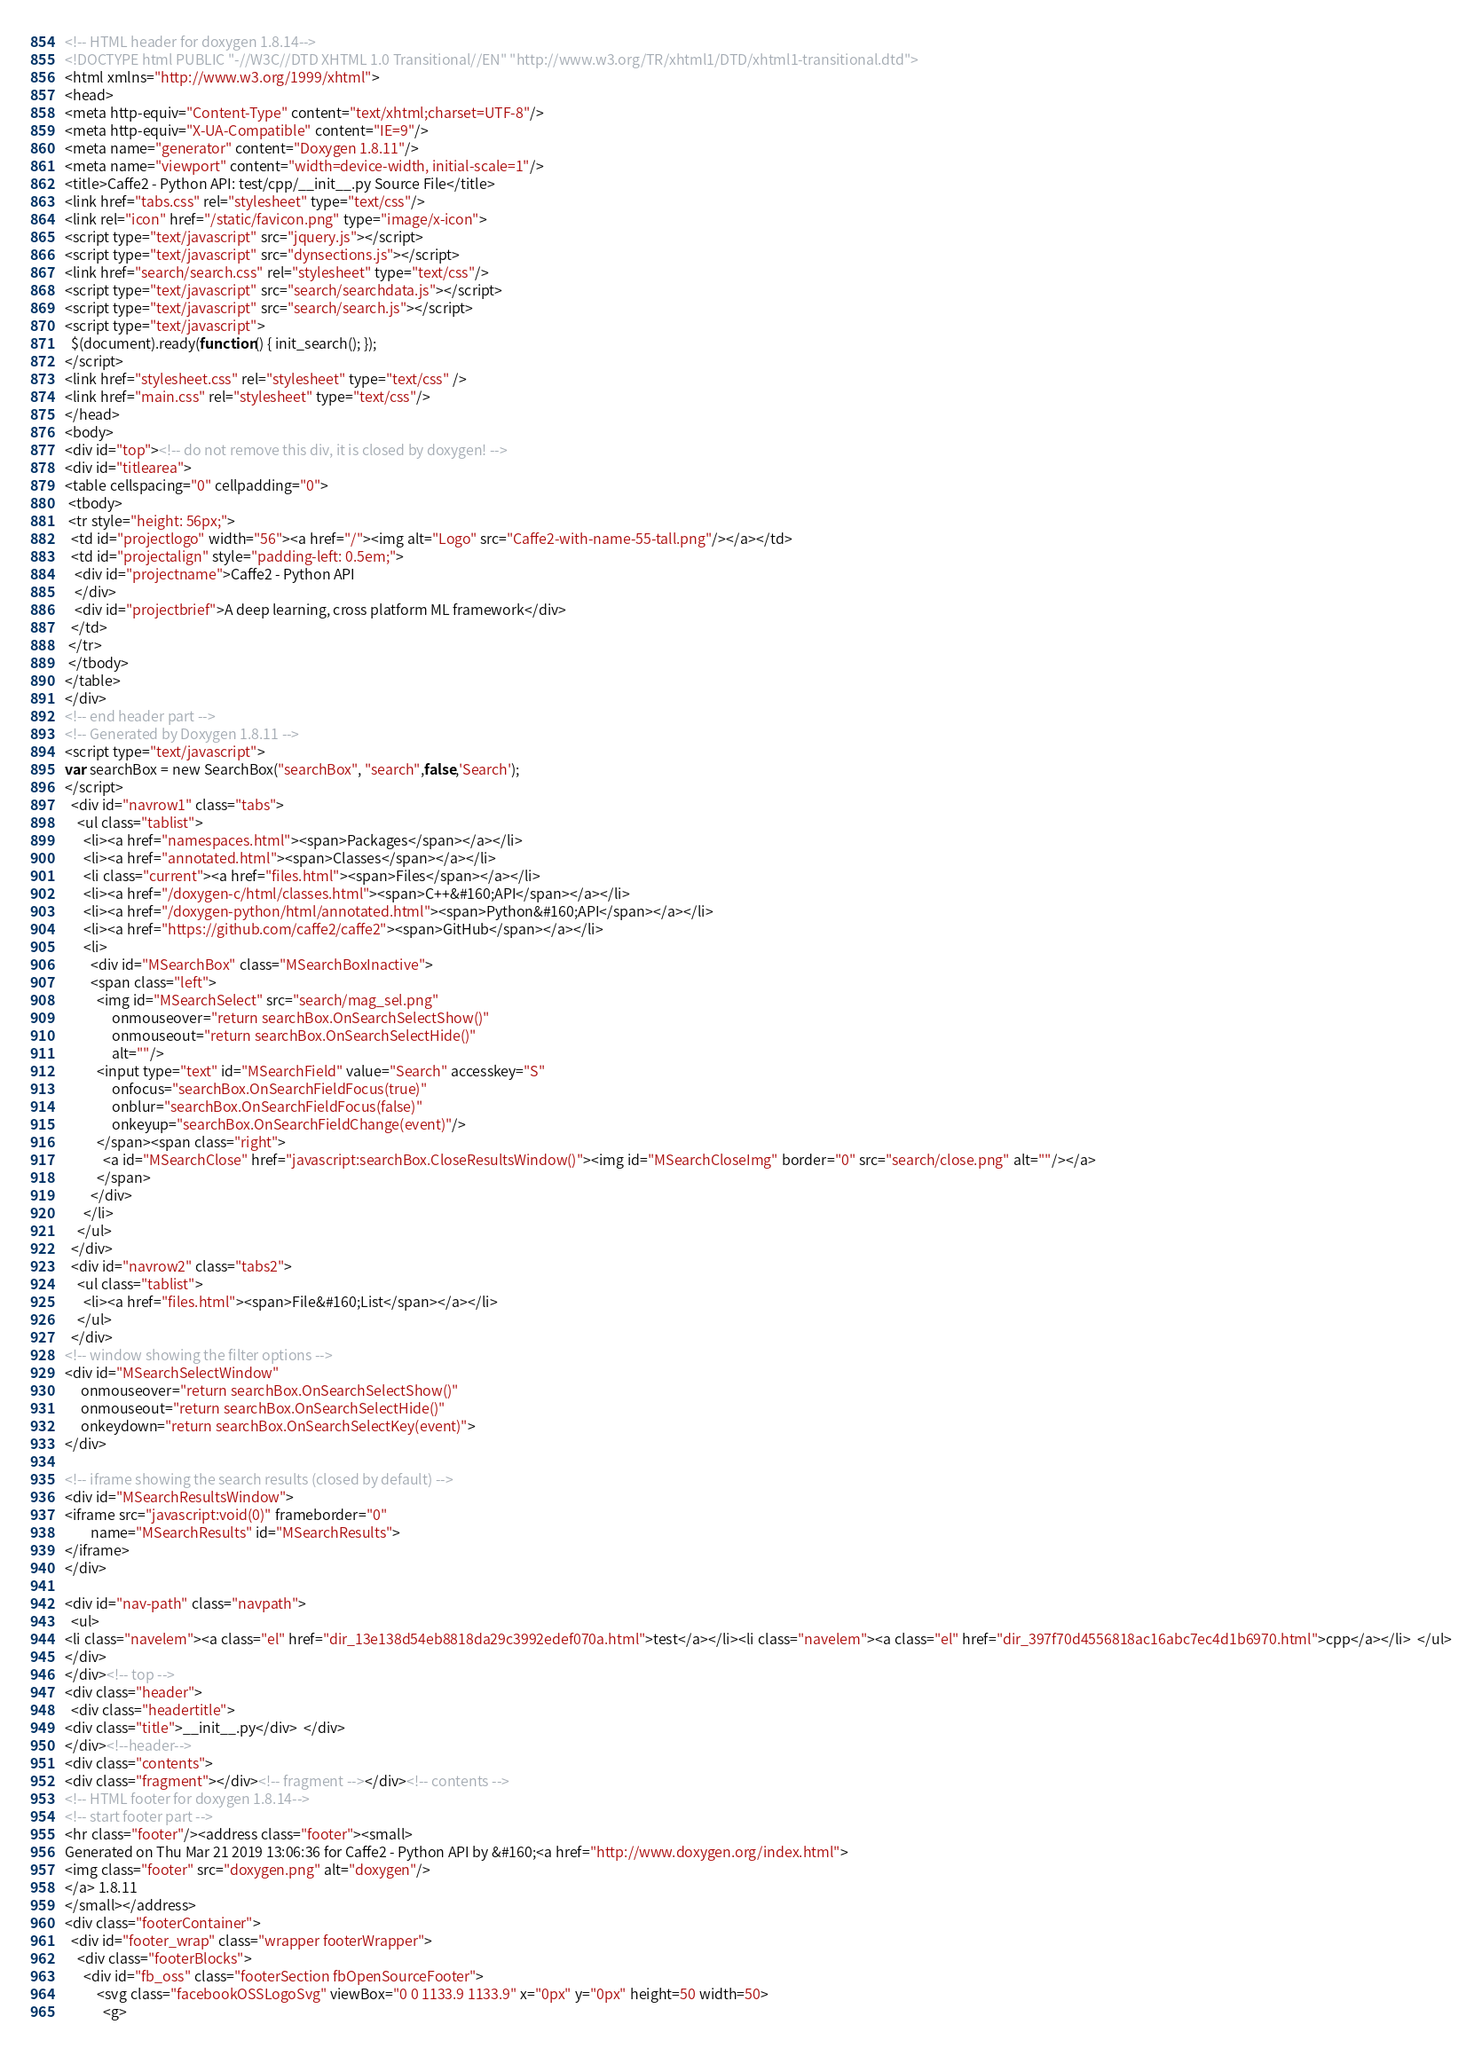Convert code to text. <code><loc_0><loc_0><loc_500><loc_500><_HTML_><!-- HTML header for doxygen 1.8.14-->
<!DOCTYPE html PUBLIC "-//W3C//DTD XHTML 1.0 Transitional//EN" "http://www.w3.org/TR/xhtml1/DTD/xhtml1-transitional.dtd">
<html xmlns="http://www.w3.org/1999/xhtml">
<head>
<meta http-equiv="Content-Type" content="text/xhtml;charset=UTF-8"/>
<meta http-equiv="X-UA-Compatible" content="IE=9"/>
<meta name="generator" content="Doxygen 1.8.11"/>
<meta name="viewport" content="width=device-width, initial-scale=1"/>
<title>Caffe2 - Python API: test/cpp/__init__.py Source File</title>
<link href="tabs.css" rel="stylesheet" type="text/css"/>
<link rel="icon" href="/static/favicon.png" type="image/x-icon">
<script type="text/javascript" src="jquery.js"></script>
<script type="text/javascript" src="dynsections.js"></script>
<link href="search/search.css" rel="stylesheet" type="text/css"/>
<script type="text/javascript" src="search/searchdata.js"></script>
<script type="text/javascript" src="search/search.js"></script>
<script type="text/javascript">
  $(document).ready(function() { init_search(); });
</script>
<link href="stylesheet.css" rel="stylesheet" type="text/css" />
<link href="main.css" rel="stylesheet" type="text/css"/>
</head>
<body>
<div id="top"><!-- do not remove this div, it is closed by doxygen! -->
<div id="titlearea">
<table cellspacing="0" cellpadding="0">
 <tbody>
 <tr style="height: 56px;">
  <td id="projectlogo" width="56"><a href="/"><img alt="Logo" src="Caffe2-with-name-55-tall.png"/></a></td>
  <td id="projectalign" style="padding-left: 0.5em;">
   <div id="projectname">Caffe2 - Python API
   </div>
   <div id="projectbrief">A deep learning, cross platform ML framework</div>
  </td>
 </tr>
 </tbody>
</table>
</div>
<!-- end header part -->
<!-- Generated by Doxygen 1.8.11 -->
<script type="text/javascript">
var searchBox = new SearchBox("searchBox", "search",false,'Search');
</script>
  <div id="navrow1" class="tabs">
    <ul class="tablist">
      <li><a href="namespaces.html"><span>Packages</span></a></li>
      <li><a href="annotated.html"><span>Classes</span></a></li>
      <li class="current"><a href="files.html"><span>Files</span></a></li>
      <li><a href="/doxygen-c/html/classes.html"><span>C++&#160;API</span></a></li>
      <li><a href="/doxygen-python/html/annotated.html"><span>Python&#160;API</span></a></li>
      <li><a href="https://github.com/caffe2/caffe2"><span>GitHub</span></a></li>
      <li>
        <div id="MSearchBox" class="MSearchBoxInactive">
        <span class="left">
          <img id="MSearchSelect" src="search/mag_sel.png"
               onmouseover="return searchBox.OnSearchSelectShow()"
               onmouseout="return searchBox.OnSearchSelectHide()"
               alt=""/>
          <input type="text" id="MSearchField" value="Search" accesskey="S"
               onfocus="searchBox.OnSearchFieldFocus(true)" 
               onblur="searchBox.OnSearchFieldFocus(false)" 
               onkeyup="searchBox.OnSearchFieldChange(event)"/>
          </span><span class="right">
            <a id="MSearchClose" href="javascript:searchBox.CloseResultsWindow()"><img id="MSearchCloseImg" border="0" src="search/close.png" alt=""/></a>
          </span>
        </div>
      </li>
    </ul>
  </div>
  <div id="navrow2" class="tabs2">
    <ul class="tablist">
      <li><a href="files.html"><span>File&#160;List</span></a></li>
    </ul>
  </div>
<!-- window showing the filter options -->
<div id="MSearchSelectWindow"
     onmouseover="return searchBox.OnSearchSelectShow()"
     onmouseout="return searchBox.OnSearchSelectHide()"
     onkeydown="return searchBox.OnSearchSelectKey(event)">
</div>

<!-- iframe showing the search results (closed by default) -->
<div id="MSearchResultsWindow">
<iframe src="javascript:void(0)" frameborder="0" 
        name="MSearchResults" id="MSearchResults">
</iframe>
</div>

<div id="nav-path" class="navpath">
  <ul>
<li class="navelem"><a class="el" href="dir_13e138d54eb8818da29c3992edef070a.html">test</a></li><li class="navelem"><a class="el" href="dir_397f70d4556818ac16abc7ec4d1b6970.html">cpp</a></li>  </ul>
</div>
</div><!-- top -->
<div class="header">
  <div class="headertitle">
<div class="title">__init__.py</div>  </div>
</div><!--header-->
<div class="contents">
<div class="fragment"></div><!-- fragment --></div><!-- contents -->
<!-- HTML footer for doxygen 1.8.14-->
<!-- start footer part -->
<hr class="footer"/><address class="footer"><small>
Generated on Thu Mar 21 2019 13:06:36 for Caffe2 - Python API by &#160;<a href="http://www.doxygen.org/index.html">
<img class="footer" src="doxygen.png" alt="doxygen"/>
</a> 1.8.11
</small></address>
<div class="footerContainer">
  <div id="footer_wrap" class="wrapper footerWrapper">
    <div class="footerBlocks">
      <div id="fb_oss" class="footerSection fbOpenSourceFooter">
          <svg class="facebookOSSLogoSvg" viewBox="0 0 1133.9 1133.9" x="0px" y="0px" height=50 width=50>
            <g></code> 